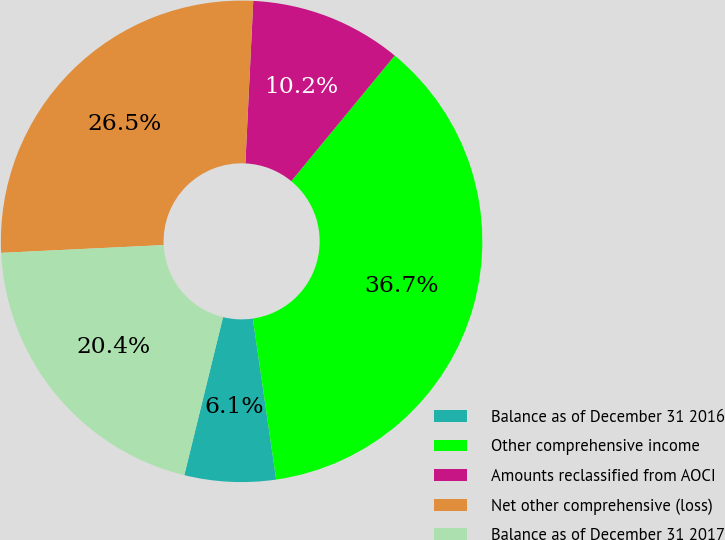Convert chart to OTSL. <chart><loc_0><loc_0><loc_500><loc_500><pie_chart><fcel>Balance as of December 31 2016<fcel>Other comprehensive income<fcel>Amounts reclassified from AOCI<fcel>Net other comprehensive (loss)<fcel>Balance as of December 31 2017<nl><fcel>6.12%<fcel>36.73%<fcel>10.2%<fcel>26.53%<fcel>20.41%<nl></chart> 